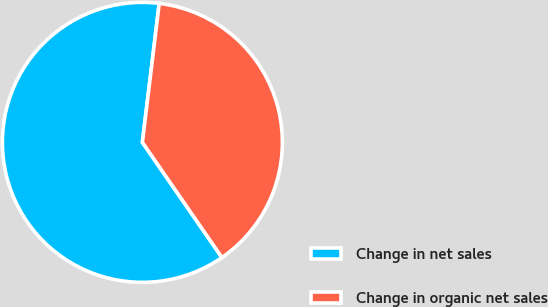Convert chart. <chart><loc_0><loc_0><loc_500><loc_500><pie_chart><fcel>Change in net sales<fcel>Change in organic net sales<nl><fcel>61.54%<fcel>38.46%<nl></chart> 